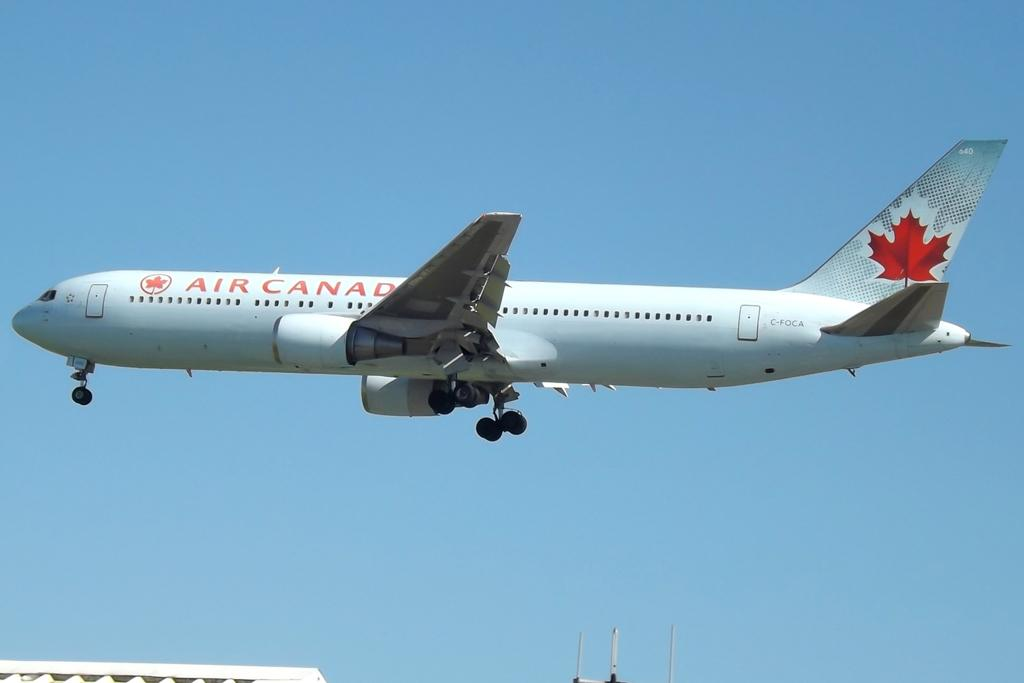Provide a one-sentence caption for the provided image. A jet plane from Air Canada is flying through the air. 